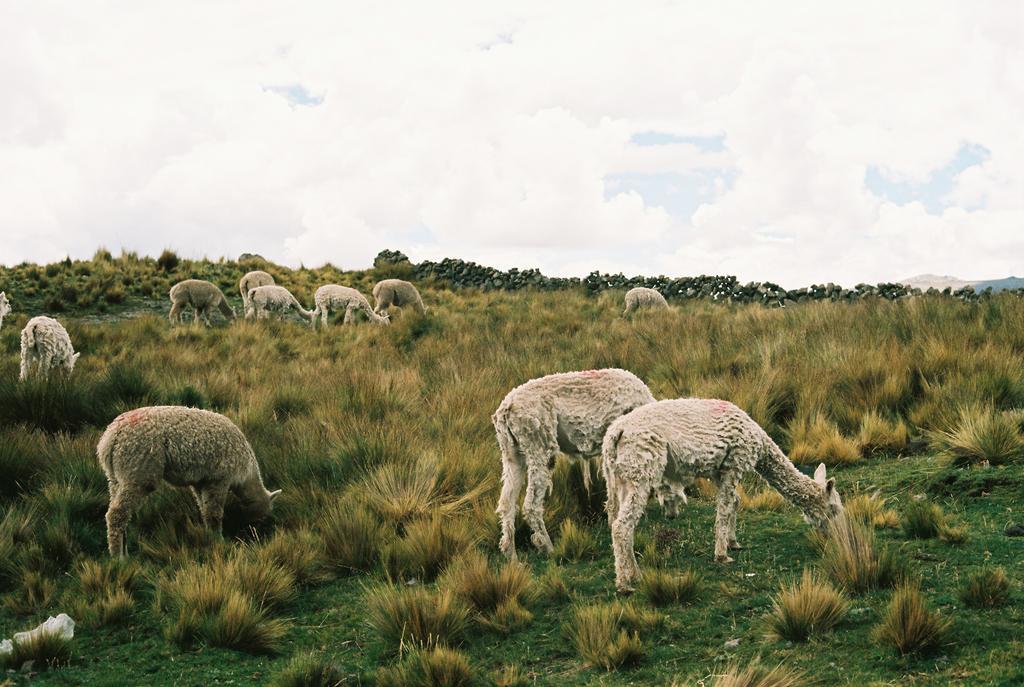Please provide a concise description of this image. In this picture I can see few sheep. I can see plants and grass on the ground and a cloudy sky. 